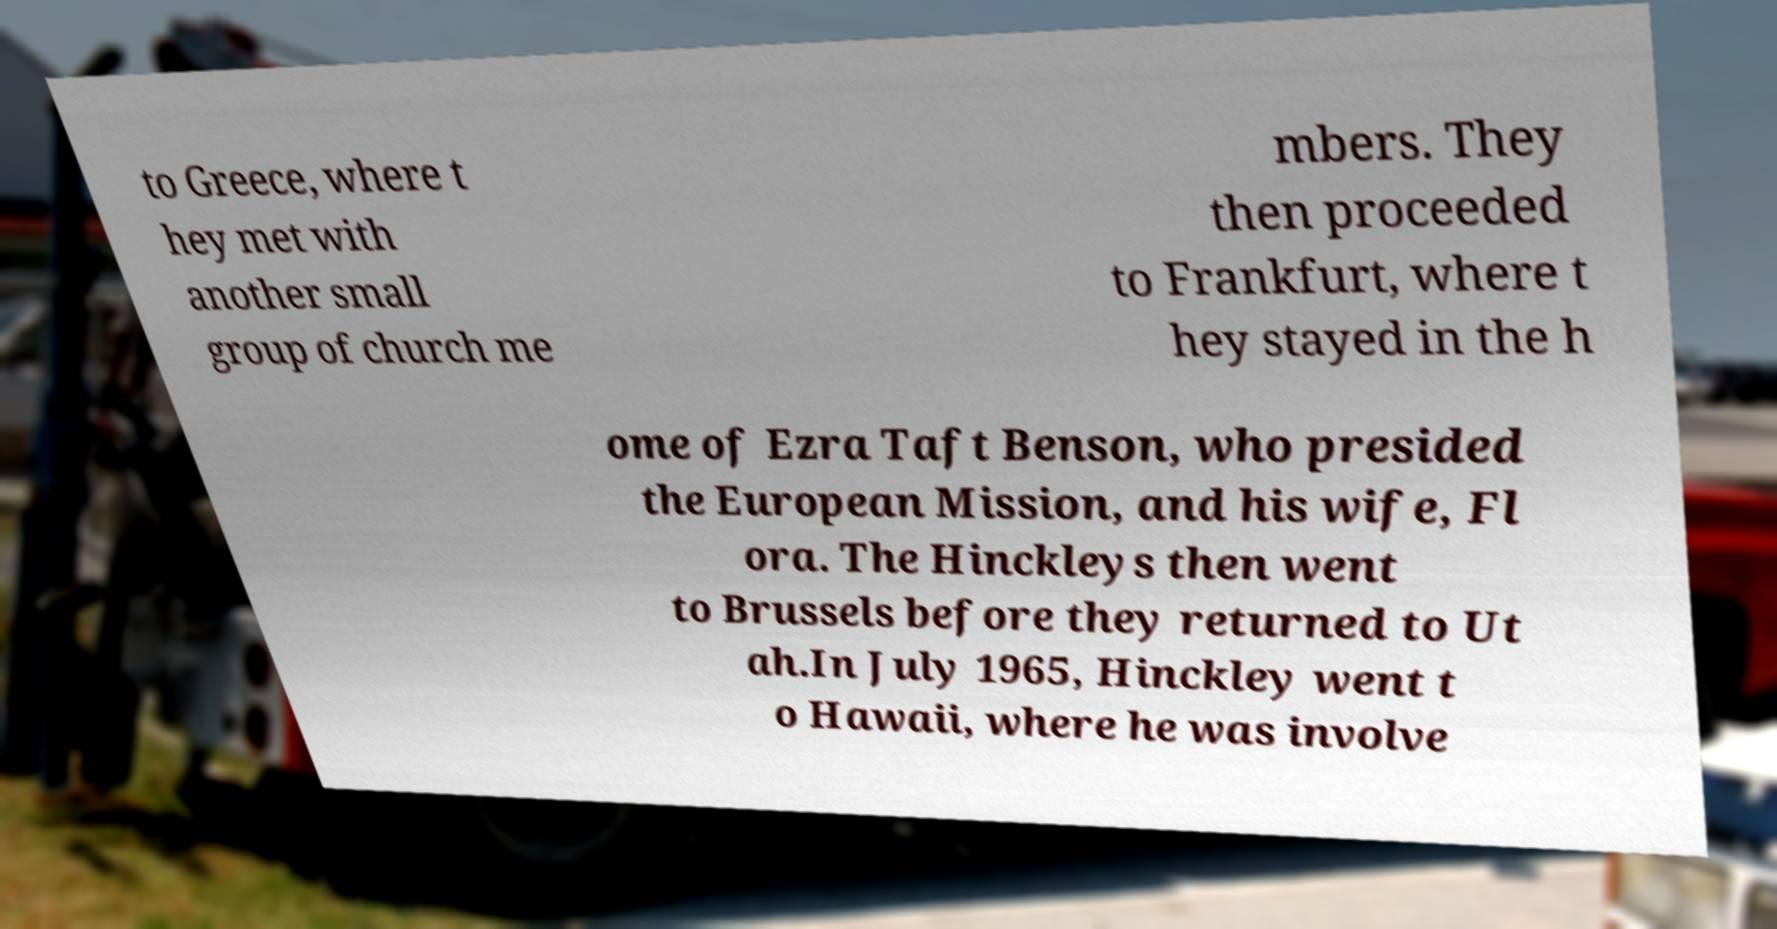Please identify and transcribe the text found in this image. to Greece, where t hey met with another small group of church me mbers. They then proceeded to Frankfurt, where t hey stayed in the h ome of Ezra Taft Benson, who presided the European Mission, and his wife, Fl ora. The Hinckleys then went to Brussels before they returned to Ut ah.In July 1965, Hinckley went t o Hawaii, where he was involve 